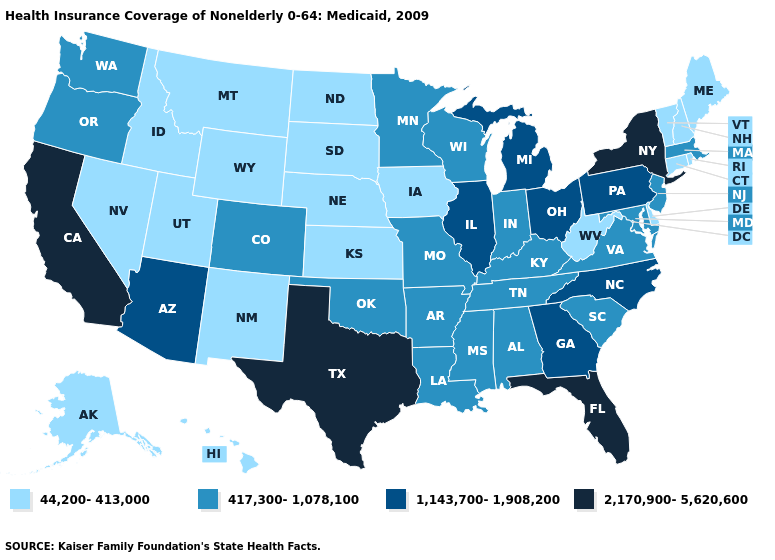Does New Mexico have the lowest value in the USA?
Be succinct. Yes. What is the value of Rhode Island?
Answer briefly. 44,200-413,000. Is the legend a continuous bar?
Quick response, please. No. What is the highest value in the MidWest ?
Keep it brief. 1,143,700-1,908,200. Among the states that border California , does Arizona have the lowest value?
Keep it brief. No. Does California have the highest value in the USA?
Be succinct. Yes. What is the value of Arizona?
Give a very brief answer. 1,143,700-1,908,200. What is the lowest value in the USA?
Concise answer only. 44,200-413,000. Which states have the lowest value in the USA?
Quick response, please. Alaska, Connecticut, Delaware, Hawaii, Idaho, Iowa, Kansas, Maine, Montana, Nebraska, Nevada, New Hampshire, New Mexico, North Dakota, Rhode Island, South Dakota, Utah, Vermont, West Virginia, Wyoming. What is the highest value in states that border Florida?
Keep it brief. 1,143,700-1,908,200. Name the states that have a value in the range 2,170,900-5,620,600?
Concise answer only. California, Florida, New York, Texas. What is the lowest value in the USA?
Be succinct. 44,200-413,000. Among the states that border Colorado , does Oklahoma have the lowest value?
Quick response, please. No. Name the states that have a value in the range 417,300-1,078,100?
Answer briefly. Alabama, Arkansas, Colorado, Indiana, Kentucky, Louisiana, Maryland, Massachusetts, Minnesota, Mississippi, Missouri, New Jersey, Oklahoma, Oregon, South Carolina, Tennessee, Virginia, Washington, Wisconsin. 